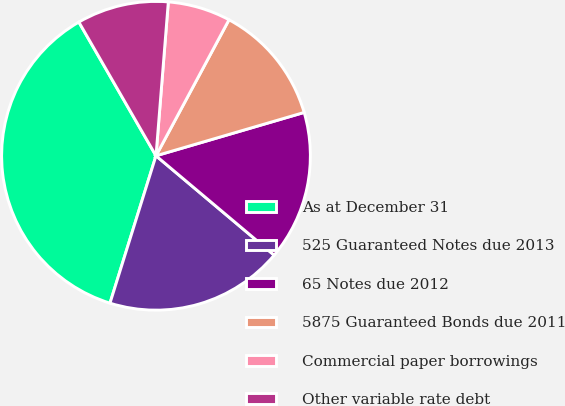Convert chart to OTSL. <chart><loc_0><loc_0><loc_500><loc_500><pie_chart><fcel>As at December 31<fcel>525 Guaranteed Notes due 2013<fcel>65 Notes due 2012<fcel>5875 Guaranteed Bonds due 2011<fcel>Commercial paper borrowings<fcel>Other variable rate debt<nl><fcel>36.86%<fcel>18.69%<fcel>15.66%<fcel>12.63%<fcel>6.57%<fcel>9.6%<nl></chart> 